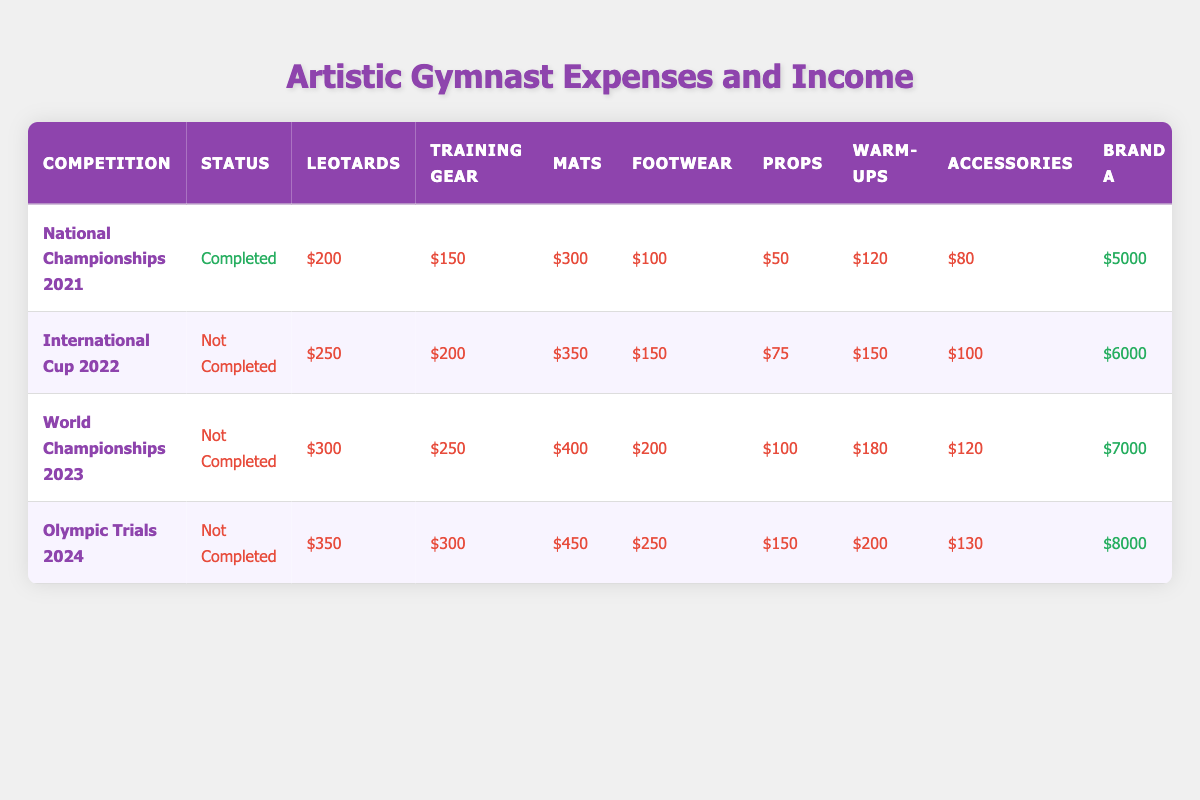What were the total equipment expenses at the National Championships 2021? To find the total equipment expenses for the National Championships 2021, add the values of all equipment items: Leotards ($200) + Training Gear ($150) + Mats ($300) + Footwear ($100) + Props ($50) = $800.
Answer: $800 What is the total sponsorship income from Brand C for all competitions? The total sponsorship income from Brand C is calculated by summing the values: Brand C for National Championships 2021 ($2000) + International Cup 2022 ($2500) + World Championships 2023 ($3000) + Olympic Trials 2024 ($3500) = $11000.
Answer: $11000 Did the equipment expenses increase from the National Championships 2021 to the Olympic Trials 2024? Yes, the equipment expenses increased from $800 in National Championships 2021 to $1300 in Olympic Trials 2024, indicating an increase.
Answer: Yes What was the average apparel expense across all competitions? The total apparel expenses across all competitions are calculated by summing all warm-ups and accessories expenses and then averaging them. So, (Warm-ups: $120 + $150 + $180 + $200) + (Accessories: $80 + $100 + $120 + $130) = $1100. There are 8 entries, so the average is $1100 / 8 = $137.5.
Answer: $137.5 What was the highest total sponsorship income in a single competition? To find the highest total sponsorship income, sum the sponsorship incomes for each competition: National Championships 2021 ($5000 + $3000 + $2000 = $10000), International Cup 2022 ($6000 + $4000 + $2500 = $12500), World Championships 2023 ($7000 + $5000 + $3000 = $15000), and Olympic Trials 2024 ($8000 + $6000 + $3500 = $17500). The highest total is $17500 from Olympic Trials 2024.
Answer: $17500 Are all equipment expenditures in 2023 higher than those in 2021? No, comparing each category: Leotards ($300 > $200), Training Gear ($250 > $150), Mats ($400 > $300), Footwear ($200 > $100), and Props ($100 > $50) shows all categories have increased from 2021 to 2023.
Answer: Yes How much more was spent on footwear for the Olympic Trials 2024 than for the National Championships 2021? The difference in footwear expenses is calculated by subtracting National Championships 2021's footwear expense ($100) from Olympic Trials 2024's footwear expense ($250): $250 - $100 = $150.
Answer: $150 Which competition had the least amount spent on accessories? By inspecting the accessory expenses for each competition: National Championships 2021 ($80), International Cup 2022 ($100), World Championships 2023 ($120), Olympic Trials 2024 ($130), the least amount spent on accessories was $80 in National Championships 2021.
Answer: National Championships 2021 What is the total expense for equipment and apparel for the World Championships 2023? The total expense for World Championships 2023 combines equipment ($300 + $250 + $400 + $200 + $100 = $1350) and apparel expenses ($180 + $120 = $300): Total = $1350 + $300 = $1650.
Answer: $1650 Which competition had the highest expenses in props? The prop expenses are: National Championships 2021 ($50), International Cup 2022 ($75), World Championships 2023 ($100), Olympic Trials 2024 ($150). The highest expense in props is $150 for Olympic Trials 2024.
Answer: Olympic Trials 2024 